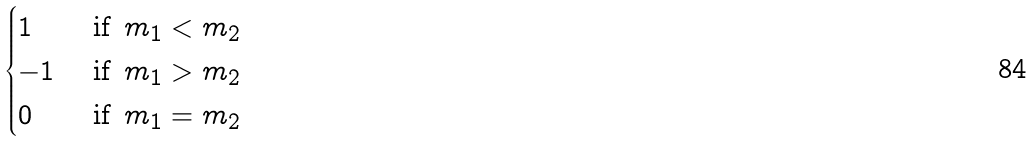Convert formula to latex. <formula><loc_0><loc_0><loc_500><loc_500>\begin{cases} 1 & \text { if } \, m _ { 1 } < m _ { 2 } \\ - 1 & \text { if } \, m _ { 1 } > m _ { 2 } \\ 0 & \text { if } \, m _ { 1 } = m _ { 2 } \end{cases}</formula> 